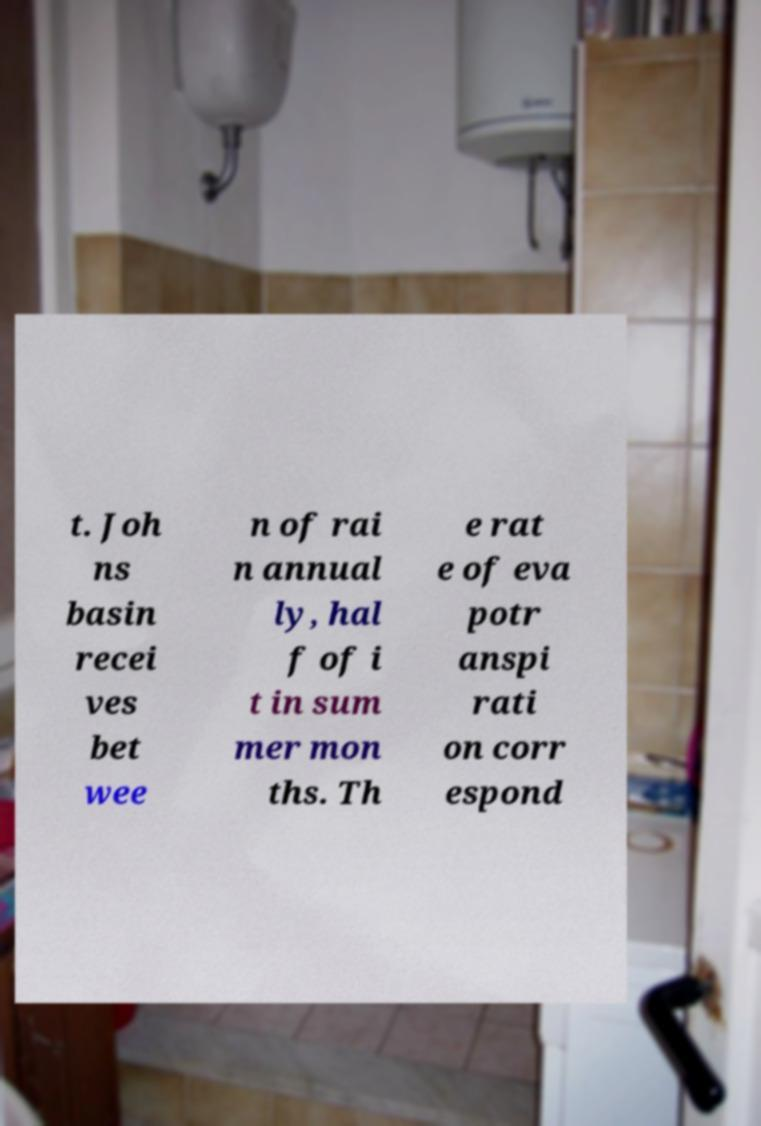Can you read and provide the text displayed in the image?This photo seems to have some interesting text. Can you extract and type it out for me? t. Joh ns basin recei ves bet wee n of rai n annual ly, hal f of i t in sum mer mon ths. Th e rat e of eva potr anspi rati on corr espond 